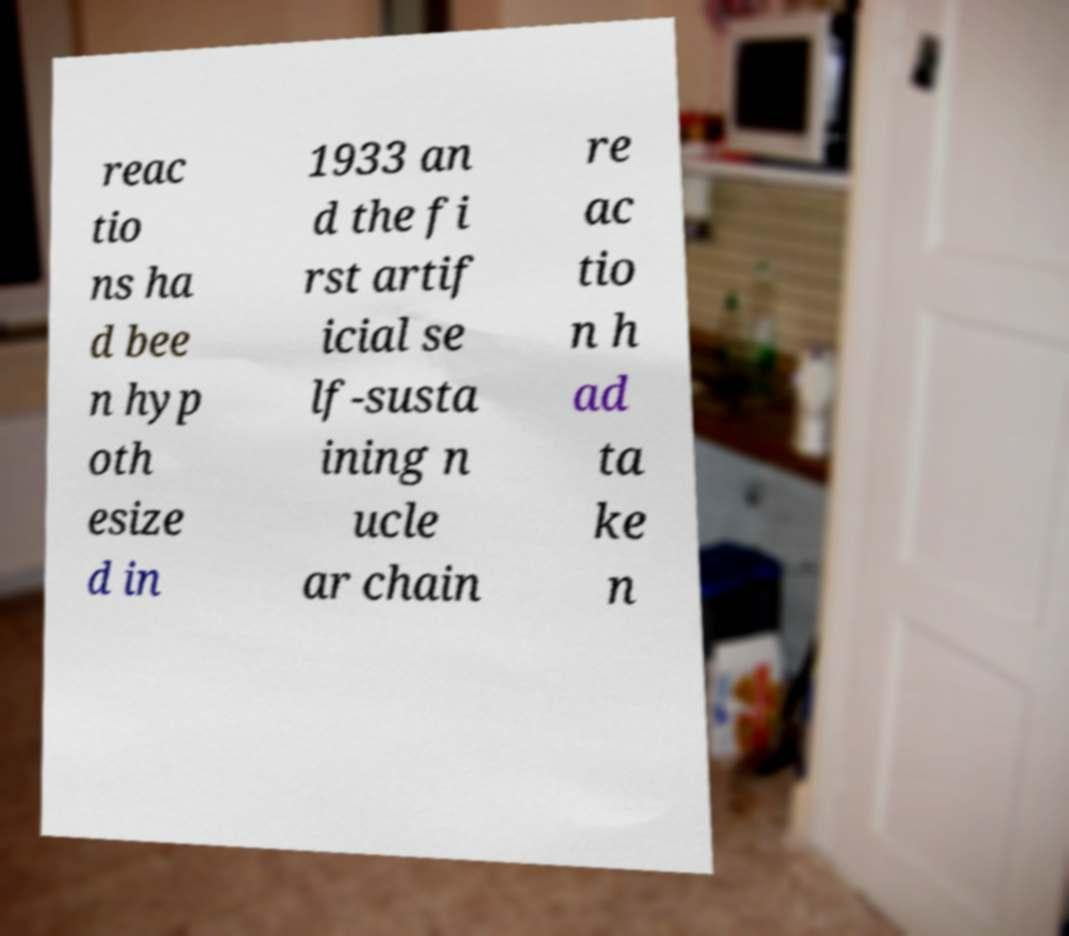Could you extract and type out the text from this image? reac tio ns ha d bee n hyp oth esize d in 1933 an d the fi rst artif icial se lf-susta ining n ucle ar chain re ac tio n h ad ta ke n 